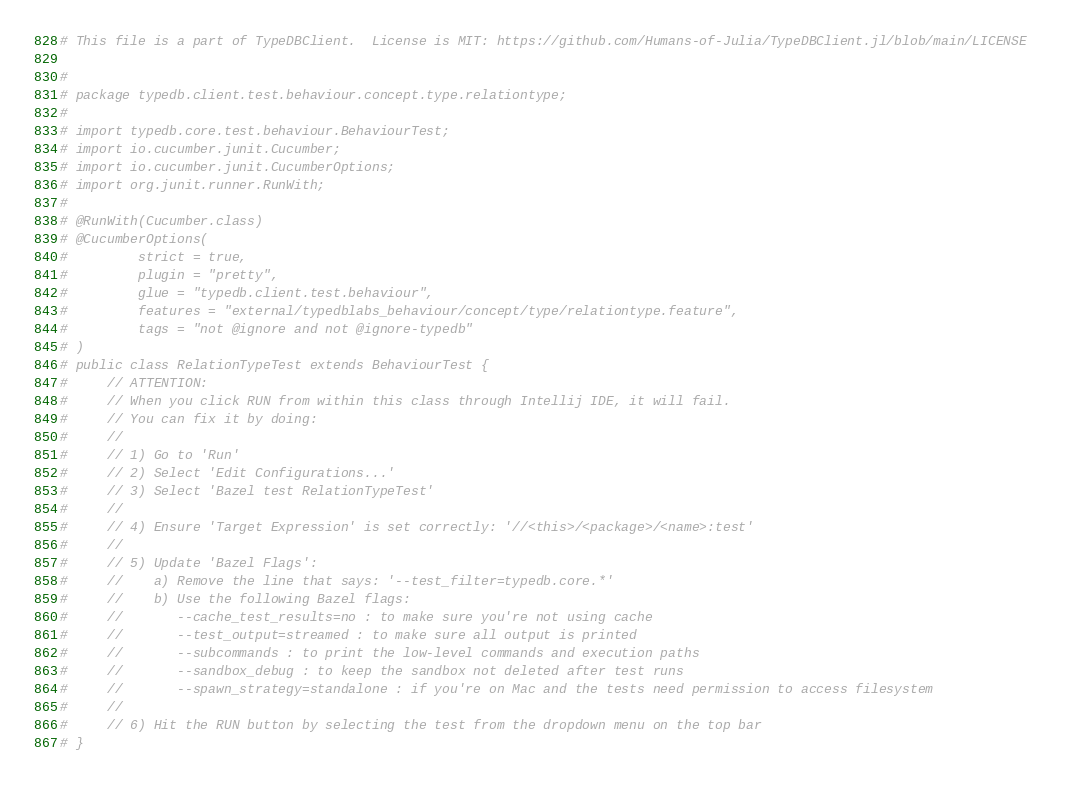<code> <loc_0><loc_0><loc_500><loc_500><_Julia_># This file is a part of TypeDBClient.  License is MIT: https://github.com/Humans-of-Julia/TypeDBClient.jl/blob/main/LICENSE 

# 
# package typedb.client.test.behaviour.concept.type.relationtype;
# 
# import typedb.core.test.behaviour.BehaviourTest;
# import io.cucumber.junit.Cucumber;
# import io.cucumber.junit.CucumberOptions;
# import org.junit.runner.RunWith;
# 
# @RunWith(Cucumber.class)
# @CucumberOptions(
#         strict = true,
#         plugin = "pretty",
#         glue = "typedb.client.test.behaviour",
#         features = "external/typedblabs_behaviour/concept/type/relationtype.feature",
#         tags = "not @ignore and not @ignore-typedb"
# )
# public class RelationTypeTest extends BehaviourTest {
#     // ATTENTION:
#     // When you click RUN from within this class through Intellij IDE, it will fail.
#     // You can fix it by doing:
#     //
#     // 1) Go to 'Run'
#     // 2) Select 'Edit Configurations...'
#     // 3) Select 'Bazel test RelationTypeTest'
#     //
#     // 4) Ensure 'Target Expression' is set correctly: '//<this>/<package>/<name>:test'
#     //
#     // 5) Update 'Bazel Flags':
#     //    a) Remove the line that says: '--test_filter=typedb.core.*'
#     //    b) Use the following Bazel flags:
#     //       --cache_test_results=no : to make sure you're not using cache
#     //       --test_output=streamed : to make sure all output is printed
#     //       --subcommands : to print the low-level commands and execution paths
#     //       --sandbox_debug : to keep the sandbox not deleted after test runs
#     //       --spawn_strategy=standalone : if you're on Mac and the tests need permission to access filesystem
#     //
#     // 6) Hit the RUN button by selecting the test from the dropdown menu on the top bar
# }
</code> 